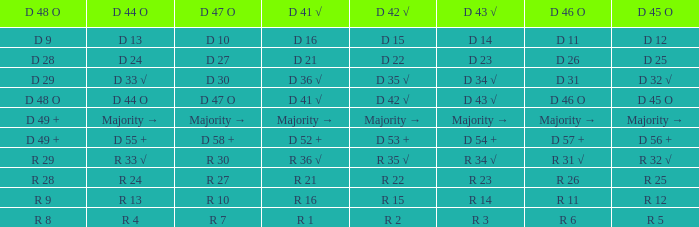Name the D 45 O with D 44 O majority → Majority →. 